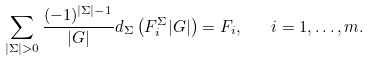Convert formula to latex. <formula><loc_0><loc_0><loc_500><loc_500>\sum _ { | \Sigma | > 0 } \frac { ( - 1 ) ^ { | \Sigma | - 1 } } { | G | } d _ { \Sigma } \left ( F ^ { \Sigma } _ { i } | G | \right ) = F _ { i } , \quad i = 1 , \dots , m .</formula> 